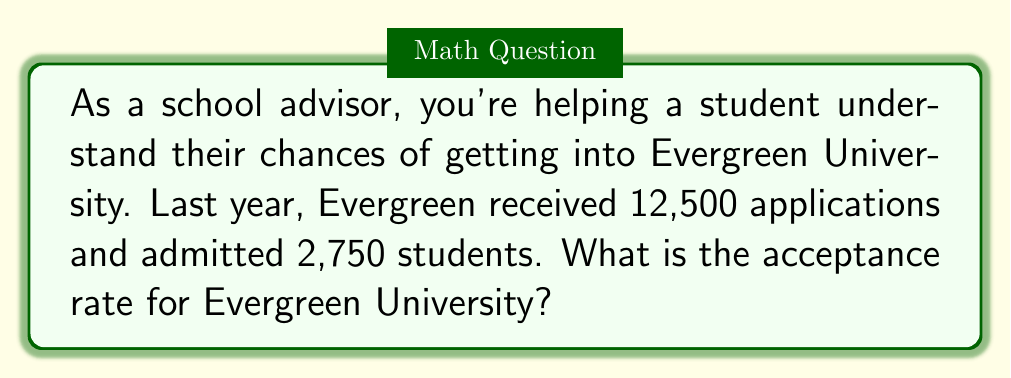Show me your answer to this math problem. To solve this problem, we need to understand that the acceptance rate is the proportion of admitted students to the total number of applicants. We can calculate this using the following steps:

1. Identify the given information:
   - Total number of applications: 12,500
   - Number of admitted students: 2,750

2. Set up the formula for acceptance rate:
   $$ \text{Acceptance Rate} = \frac{\text{Number of Admitted Students}}{\text{Total Number of Applications}} \times 100\% $$

3. Plug in the values:
   $$ \text{Acceptance Rate} = \frac{2,750}{12,500} \times 100\% $$

4. Perform the division:
   $$ \text{Acceptance Rate} = 0.22 \times 100\% $$

5. Convert to a percentage:
   $$ \text{Acceptance Rate} = 22\% $$

Therefore, the acceptance rate for Evergreen University is 22%.
Answer: 22% 